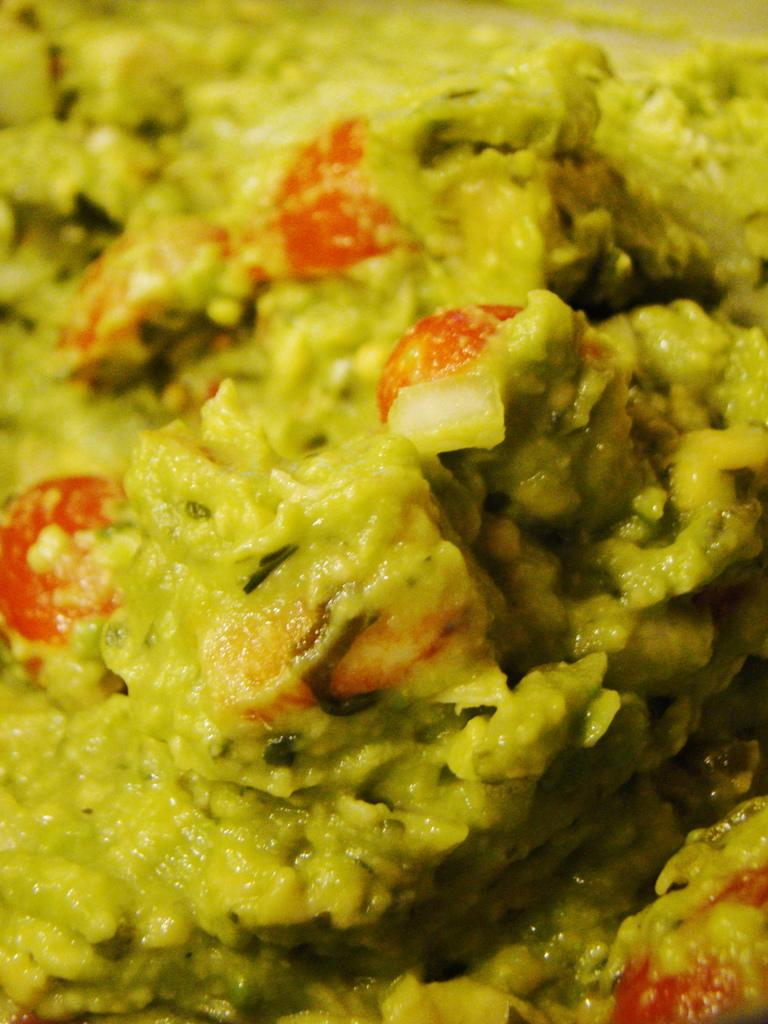What is the main subject of the image? There is a food item in the image. What type of parenting advice can be found on the calculator in the image? There is no calculator or parenting advice present in the image; it only features a food item. 